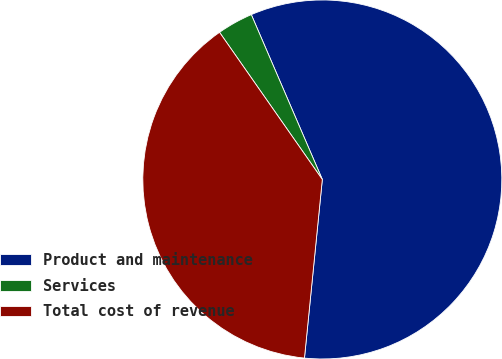Convert chart to OTSL. <chart><loc_0><loc_0><loc_500><loc_500><pie_chart><fcel>Product and maintenance<fcel>Services<fcel>Total cost of revenue<nl><fcel>58.06%<fcel>3.23%<fcel>38.71%<nl></chart> 